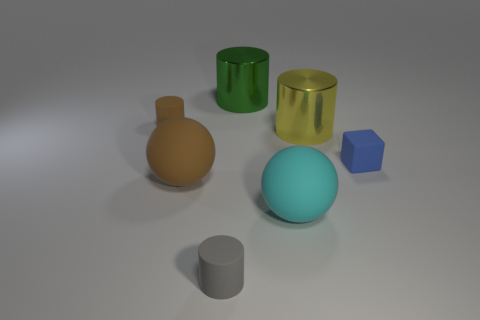The tiny matte cylinder that is behind the yellow cylinder is what color?
Provide a short and direct response. Brown. Is there a big green object behind the big shiny cylinder that is behind the big yellow shiny object?
Give a very brief answer. No. Is the number of gray matte objects less than the number of small brown matte spheres?
Offer a terse response. No. What is the material of the cylinder that is on the right side of the large metallic cylinder left of the cyan matte object?
Keep it short and to the point. Metal. Do the yellow object and the green object have the same size?
Your answer should be compact. Yes. What number of objects are blue rubber cylinders or big spheres?
Make the answer very short. 2. There is a object that is left of the gray thing and behind the blue block; how big is it?
Provide a succinct answer. Small. Is the number of large rubber objects in front of the gray cylinder less than the number of big brown cylinders?
Give a very brief answer. No. There is a cyan object that is the same material as the gray object; what shape is it?
Provide a succinct answer. Sphere. There is a matte object behind the blue rubber cube; is its shape the same as the tiny object in front of the tiny blue object?
Give a very brief answer. Yes. 